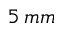Convert formula to latex. <formula><loc_0><loc_0><loc_500><loc_500>5 \, m m</formula> 